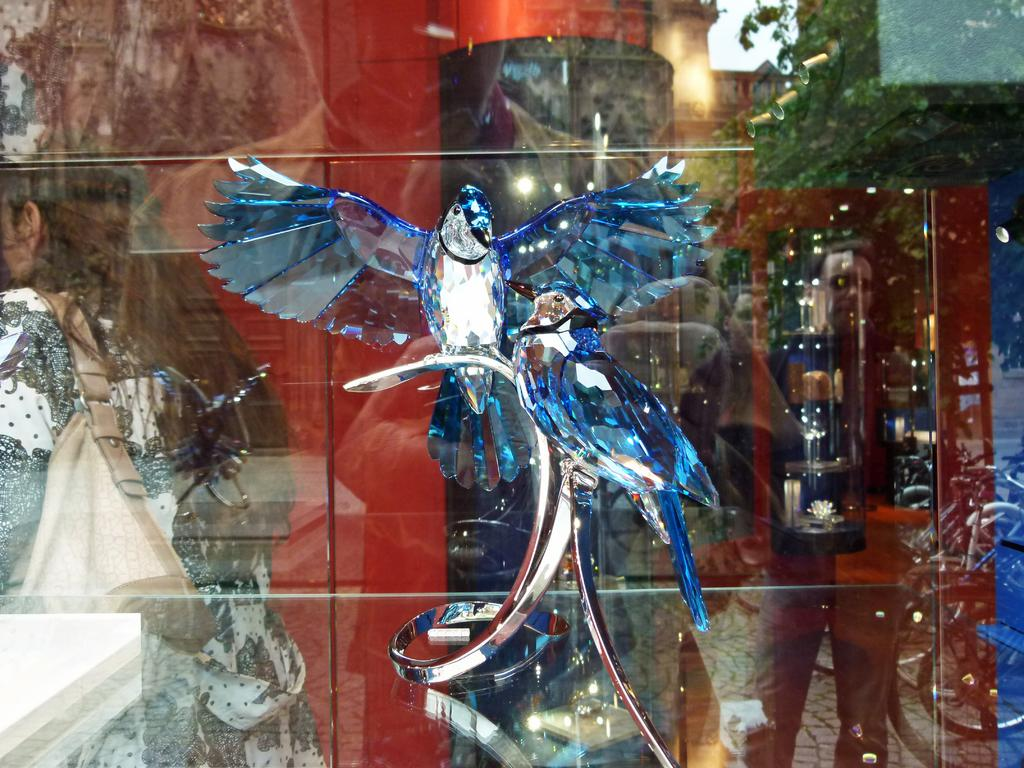What type of decorative object can be seen in the image? There is a crystal decorative object in the image. What is the material of the wall that has reflections on it? The wall is made of glass. What can be seen in the reflections on the glass wall? There are reflections of people and trees on the glass wall. Can you describe the person wearing a bag in the image? There is a person wearing a bag in the image. What type of detail can be seen on the grandmother's dress in the image? There is no grandmother present in the image, and therefore no dress or detail to describe. What type of arch can be seen in the image? There is no arch present in the image. 